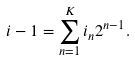<formula> <loc_0><loc_0><loc_500><loc_500>i - 1 = \sum _ { n = 1 } ^ { K } i _ { n } 2 ^ { n - 1 } .</formula> 